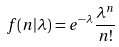<formula> <loc_0><loc_0><loc_500><loc_500>f ( n | \lambda ) = e ^ { - \lambda } \frac { \lambda ^ { n } } { n ! }</formula> 